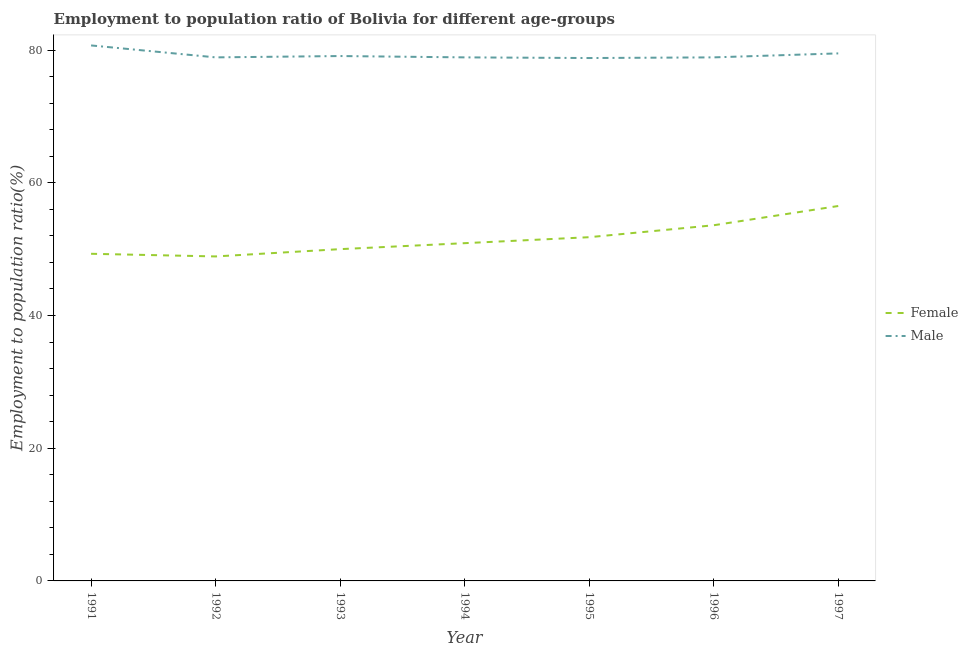Does the line corresponding to employment to population ratio(male) intersect with the line corresponding to employment to population ratio(female)?
Your answer should be compact. No. What is the employment to population ratio(male) in 1994?
Your answer should be very brief. 78.9. Across all years, what is the maximum employment to population ratio(male)?
Make the answer very short. 80.7. Across all years, what is the minimum employment to population ratio(female)?
Your answer should be compact. 48.9. In which year was the employment to population ratio(female) maximum?
Provide a short and direct response. 1997. What is the total employment to population ratio(female) in the graph?
Offer a very short reply. 361. What is the difference between the employment to population ratio(male) in 1994 and that in 1995?
Your answer should be very brief. 0.1. What is the difference between the employment to population ratio(female) in 1997 and the employment to population ratio(male) in 1992?
Provide a succinct answer. -22.4. What is the average employment to population ratio(male) per year?
Provide a succinct answer. 79.26. In the year 1991, what is the difference between the employment to population ratio(male) and employment to population ratio(female)?
Offer a terse response. 31.4. In how many years, is the employment to population ratio(female) greater than 48 %?
Your answer should be very brief. 7. Is the employment to population ratio(female) in 1993 less than that in 1994?
Provide a succinct answer. Yes. What is the difference between the highest and the second highest employment to population ratio(female)?
Make the answer very short. 2.9. What is the difference between the highest and the lowest employment to population ratio(female)?
Your response must be concise. 7.6. In how many years, is the employment to population ratio(male) greater than the average employment to population ratio(male) taken over all years?
Ensure brevity in your answer.  2. Does the employment to population ratio(female) monotonically increase over the years?
Provide a short and direct response. No. Is the employment to population ratio(female) strictly less than the employment to population ratio(male) over the years?
Your answer should be compact. Yes. How many lines are there?
Provide a succinct answer. 2. Are the values on the major ticks of Y-axis written in scientific E-notation?
Your answer should be very brief. No. Does the graph contain any zero values?
Provide a short and direct response. No. Does the graph contain grids?
Provide a succinct answer. No. What is the title of the graph?
Your answer should be very brief. Employment to population ratio of Bolivia for different age-groups. Does "Urban" appear as one of the legend labels in the graph?
Give a very brief answer. No. What is the label or title of the Y-axis?
Your response must be concise. Employment to population ratio(%). What is the Employment to population ratio(%) of Female in 1991?
Offer a terse response. 49.3. What is the Employment to population ratio(%) of Male in 1991?
Offer a terse response. 80.7. What is the Employment to population ratio(%) in Female in 1992?
Give a very brief answer. 48.9. What is the Employment to population ratio(%) of Male in 1992?
Make the answer very short. 78.9. What is the Employment to population ratio(%) of Female in 1993?
Offer a very short reply. 50. What is the Employment to population ratio(%) of Male in 1993?
Keep it short and to the point. 79.1. What is the Employment to population ratio(%) of Female in 1994?
Your answer should be very brief. 50.9. What is the Employment to population ratio(%) of Male in 1994?
Give a very brief answer. 78.9. What is the Employment to population ratio(%) in Female in 1995?
Provide a succinct answer. 51.8. What is the Employment to population ratio(%) in Male in 1995?
Your answer should be compact. 78.8. What is the Employment to population ratio(%) of Female in 1996?
Your answer should be very brief. 53.6. What is the Employment to population ratio(%) in Male in 1996?
Ensure brevity in your answer.  78.9. What is the Employment to population ratio(%) in Female in 1997?
Make the answer very short. 56.5. What is the Employment to population ratio(%) in Male in 1997?
Ensure brevity in your answer.  79.5. Across all years, what is the maximum Employment to population ratio(%) of Female?
Provide a short and direct response. 56.5. Across all years, what is the maximum Employment to population ratio(%) of Male?
Ensure brevity in your answer.  80.7. Across all years, what is the minimum Employment to population ratio(%) in Female?
Make the answer very short. 48.9. Across all years, what is the minimum Employment to population ratio(%) in Male?
Offer a terse response. 78.8. What is the total Employment to population ratio(%) of Female in the graph?
Your answer should be very brief. 361. What is the total Employment to population ratio(%) of Male in the graph?
Offer a terse response. 554.8. What is the difference between the Employment to population ratio(%) in Male in 1991 and that in 1992?
Offer a terse response. 1.8. What is the difference between the Employment to population ratio(%) in Female in 1991 and that in 1993?
Give a very brief answer. -0.7. What is the difference between the Employment to population ratio(%) in Male in 1991 and that in 1993?
Ensure brevity in your answer.  1.6. What is the difference between the Employment to population ratio(%) of Male in 1991 and that in 1994?
Your answer should be very brief. 1.8. What is the difference between the Employment to population ratio(%) of Female in 1991 and that in 1995?
Your answer should be very brief. -2.5. What is the difference between the Employment to population ratio(%) in Male in 1991 and that in 1995?
Ensure brevity in your answer.  1.9. What is the difference between the Employment to population ratio(%) in Male in 1991 and that in 1996?
Your answer should be very brief. 1.8. What is the difference between the Employment to population ratio(%) of Male in 1991 and that in 1997?
Offer a terse response. 1.2. What is the difference between the Employment to population ratio(%) in Male in 1992 and that in 1993?
Provide a succinct answer. -0.2. What is the difference between the Employment to population ratio(%) of Female in 1992 and that in 1994?
Your answer should be very brief. -2. What is the difference between the Employment to population ratio(%) in Female in 1992 and that in 1996?
Ensure brevity in your answer.  -4.7. What is the difference between the Employment to population ratio(%) of Male in 1992 and that in 1996?
Your response must be concise. 0. What is the difference between the Employment to population ratio(%) of Female in 1992 and that in 1997?
Offer a terse response. -7.6. What is the difference between the Employment to population ratio(%) of Male in 1992 and that in 1997?
Ensure brevity in your answer.  -0.6. What is the difference between the Employment to population ratio(%) of Female in 1993 and that in 1994?
Provide a succinct answer. -0.9. What is the difference between the Employment to population ratio(%) of Male in 1993 and that in 1995?
Give a very brief answer. 0.3. What is the difference between the Employment to population ratio(%) of Female in 1993 and that in 1996?
Your answer should be very brief. -3.6. What is the difference between the Employment to population ratio(%) in Male in 1993 and that in 1996?
Provide a succinct answer. 0.2. What is the difference between the Employment to population ratio(%) of Female in 1994 and that in 1996?
Make the answer very short. -2.7. What is the difference between the Employment to population ratio(%) in Male in 1994 and that in 1996?
Offer a terse response. 0. What is the difference between the Employment to population ratio(%) of Female in 1995 and that in 1996?
Provide a succinct answer. -1.8. What is the difference between the Employment to population ratio(%) of Female in 1995 and that in 1997?
Ensure brevity in your answer.  -4.7. What is the difference between the Employment to population ratio(%) of Male in 1996 and that in 1997?
Provide a succinct answer. -0.6. What is the difference between the Employment to population ratio(%) in Female in 1991 and the Employment to population ratio(%) in Male in 1992?
Your answer should be compact. -29.6. What is the difference between the Employment to population ratio(%) in Female in 1991 and the Employment to population ratio(%) in Male in 1993?
Offer a very short reply. -29.8. What is the difference between the Employment to population ratio(%) of Female in 1991 and the Employment to population ratio(%) of Male in 1994?
Provide a short and direct response. -29.6. What is the difference between the Employment to population ratio(%) in Female in 1991 and the Employment to population ratio(%) in Male in 1995?
Ensure brevity in your answer.  -29.5. What is the difference between the Employment to population ratio(%) in Female in 1991 and the Employment to population ratio(%) in Male in 1996?
Make the answer very short. -29.6. What is the difference between the Employment to population ratio(%) of Female in 1991 and the Employment to population ratio(%) of Male in 1997?
Give a very brief answer. -30.2. What is the difference between the Employment to population ratio(%) in Female in 1992 and the Employment to population ratio(%) in Male in 1993?
Provide a succinct answer. -30.2. What is the difference between the Employment to population ratio(%) of Female in 1992 and the Employment to population ratio(%) of Male in 1994?
Your answer should be compact. -30. What is the difference between the Employment to population ratio(%) of Female in 1992 and the Employment to population ratio(%) of Male in 1995?
Provide a short and direct response. -29.9. What is the difference between the Employment to population ratio(%) of Female in 1992 and the Employment to population ratio(%) of Male in 1997?
Your answer should be very brief. -30.6. What is the difference between the Employment to population ratio(%) in Female in 1993 and the Employment to population ratio(%) in Male in 1994?
Your answer should be very brief. -28.9. What is the difference between the Employment to population ratio(%) of Female in 1993 and the Employment to population ratio(%) of Male in 1995?
Make the answer very short. -28.8. What is the difference between the Employment to population ratio(%) of Female in 1993 and the Employment to population ratio(%) of Male in 1996?
Keep it short and to the point. -28.9. What is the difference between the Employment to population ratio(%) in Female in 1993 and the Employment to population ratio(%) in Male in 1997?
Make the answer very short. -29.5. What is the difference between the Employment to population ratio(%) in Female in 1994 and the Employment to population ratio(%) in Male in 1995?
Your response must be concise. -27.9. What is the difference between the Employment to population ratio(%) in Female in 1994 and the Employment to population ratio(%) in Male in 1996?
Keep it short and to the point. -28. What is the difference between the Employment to population ratio(%) in Female in 1994 and the Employment to population ratio(%) in Male in 1997?
Provide a short and direct response. -28.6. What is the difference between the Employment to population ratio(%) of Female in 1995 and the Employment to population ratio(%) of Male in 1996?
Offer a very short reply. -27.1. What is the difference between the Employment to population ratio(%) in Female in 1995 and the Employment to population ratio(%) in Male in 1997?
Give a very brief answer. -27.7. What is the difference between the Employment to population ratio(%) of Female in 1996 and the Employment to population ratio(%) of Male in 1997?
Your response must be concise. -25.9. What is the average Employment to population ratio(%) of Female per year?
Ensure brevity in your answer.  51.57. What is the average Employment to population ratio(%) of Male per year?
Your response must be concise. 79.26. In the year 1991, what is the difference between the Employment to population ratio(%) of Female and Employment to population ratio(%) of Male?
Your answer should be very brief. -31.4. In the year 1993, what is the difference between the Employment to population ratio(%) in Female and Employment to population ratio(%) in Male?
Offer a very short reply. -29.1. In the year 1996, what is the difference between the Employment to population ratio(%) of Female and Employment to population ratio(%) of Male?
Your response must be concise. -25.3. What is the ratio of the Employment to population ratio(%) in Female in 1991 to that in 1992?
Provide a short and direct response. 1.01. What is the ratio of the Employment to population ratio(%) of Male in 1991 to that in 1992?
Provide a short and direct response. 1.02. What is the ratio of the Employment to population ratio(%) in Male in 1991 to that in 1993?
Provide a succinct answer. 1.02. What is the ratio of the Employment to population ratio(%) of Female in 1991 to that in 1994?
Make the answer very short. 0.97. What is the ratio of the Employment to population ratio(%) of Male in 1991 to that in 1994?
Make the answer very short. 1.02. What is the ratio of the Employment to population ratio(%) of Female in 1991 to that in 1995?
Give a very brief answer. 0.95. What is the ratio of the Employment to population ratio(%) of Male in 1991 to that in 1995?
Your answer should be compact. 1.02. What is the ratio of the Employment to population ratio(%) of Female in 1991 to that in 1996?
Your response must be concise. 0.92. What is the ratio of the Employment to population ratio(%) of Male in 1991 to that in 1996?
Your response must be concise. 1.02. What is the ratio of the Employment to population ratio(%) in Female in 1991 to that in 1997?
Keep it short and to the point. 0.87. What is the ratio of the Employment to population ratio(%) in Male in 1991 to that in 1997?
Your answer should be very brief. 1.02. What is the ratio of the Employment to population ratio(%) in Male in 1992 to that in 1993?
Keep it short and to the point. 1. What is the ratio of the Employment to population ratio(%) of Female in 1992 to that in 1994?
Ensure brevity in your answer.  0.96. What is the ratio of the Employment to population ratio(%) of Female in 1992 to that in 1995?
Offer a very short reply. 0.94. What is the ratio of the Employment to population ratio(%) of Male in 1992 to that in 1995?
Your answer should be compact. 1. What is the ratio of the Employment to population ratio(%) in Female in 1992 to that in 1996?
Provide a short and direct response. 0.91. What is the ratio of the Employment to population ratio(%) of Female in 1992 to that in 1997?
Your answer should be compact. 0.87. What is the ratio of the Employment to population ratio(%) in Male in 1992 to that in 1997?
Offer a terse response. 0.99. What is the ratio of the Employment to population ratio(%) in Female in 1993 to that in 1994?
Make the answer very short. 0.98. What is the ratio of the Employment to population ratio(%) in Female in 1993 to that in 1995?
Keep it short and to the point. 0.97. What is the ratio of the Employment to population ratio(%) of Female in 1993 to that in 1996?
Give a very brief answer. 0.93. What is the ratio of the Employment to population ratio(%) in Female in 1993 to that in 1997?
Keep it short and to the point. 0.89. What is the ratio of the Employment to population ratio(%) in Female in 1994 to that in 1995?
Offer a very short reply. 0.98. What is the ratio of the Employment to population ratio(%) of Male in 1994 to that in 1995?
Ensure brevity in your answer.  1. What is the ratio of the Employment to population ratio(%) of Female in 1994 to that in 1996?
Provide a succinct answer. 0.95. What is the ratio of the Employment to population ratio(%) of Female in 1994 to that in 1997?
Give a very brief answer. 0.9. What is the ratio of the Employment to population ratio(%) of Male in 1994 to that in 1997?
Offer a very short reply. 0.99. What is the ratio of the Employment to population ratio(%) in Female in 1995 to that in 1996?
Offer a terse response. 0.97. What is the ratio of the Employment to population ratio(%) of Female in 1995 to that in 1997?
Provide a succinct answer. 0.92. What is the ratio of the Employment to population ratio(%) in Male in 1995 to that in 1997?
Ensure brevity in your answer.  0.99. What is the ratio of the Employment to population ratio(%) of Female in 1996 to that in 1997?
Make the answer very short. 0.95. What is the ratio of the Employment to population ratio(%) in Male in 1996 to that in 1997?
Provide a succinct answer. 0.99. What is the difference between the highest and the lowest Employment to population ratio(%) of Female?
Keep it short and to the point. 7.6. 